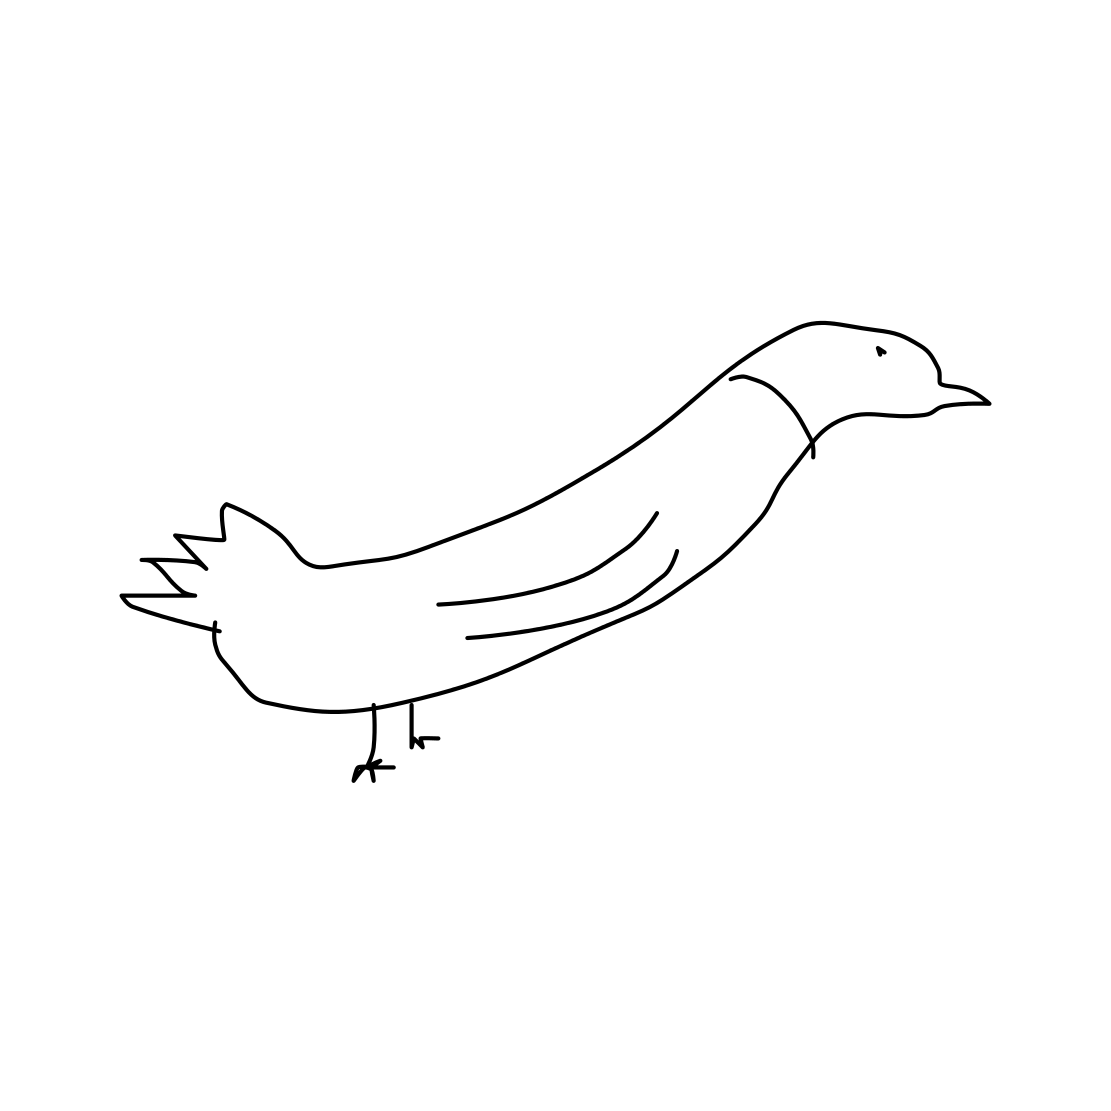Is this a tree in the image? No 